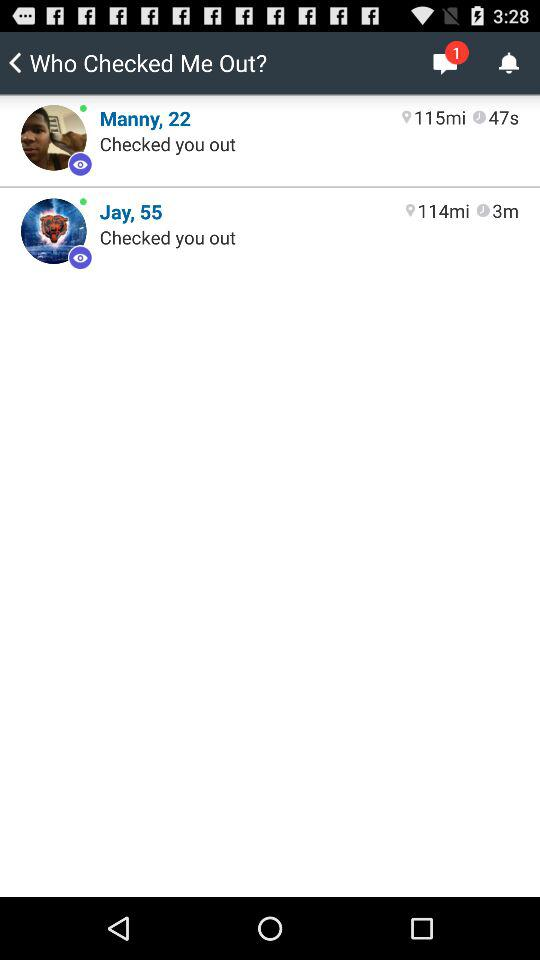When was the last time Manny checked on me? Manny last checked on you 47 seconds ago. 